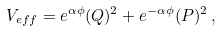<formula> <loc_0><loc_0><loc_500><loc_500>V _ { e f f } = e ^ { \alpha \phi } ( Q ) ^ { 2 } + e ^ { - \alpha \phi } ( P ) ^ { 2 } \, ,</formula> 